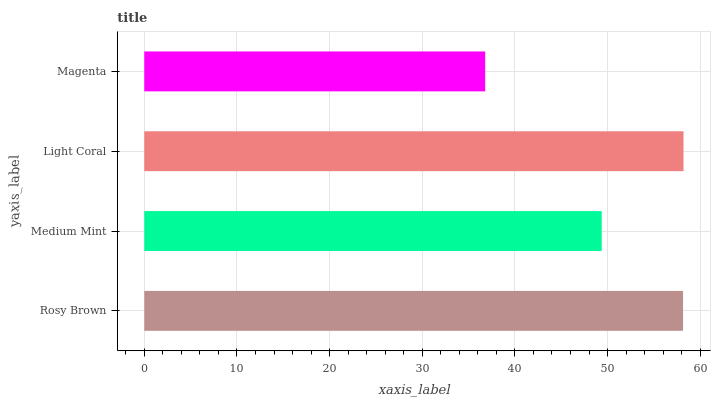Is Magenta the minimum?
Answer yes or no. Yes. Is Light Coral the maximum?
Answer yes or no. Yes. Is Medium Mint the minimum?
Answer yes or no. No. Is Medium Mint the maximum?
Answer yes or no. No. Is Rosy Brown greater than Medium Mint?
Answer yes or no. Yes. Is Medium Mint less than Rosy Brown?
Answer yes or no. Yes. Is Medium Mint greater than Rosy Brown?
Answer yes or no. No. Is Rosy Brown less than Medium Mint?
Answer yes or no. No. Is Rosy Brown the high median?
Answer yes or no. Yes. Is Medium Mint the low median?
Answer yes or no. Yes. Is Light Coral the high median?
Answer yes or no. No. Is Light Coral the low median?
Answer yes or no. No. 